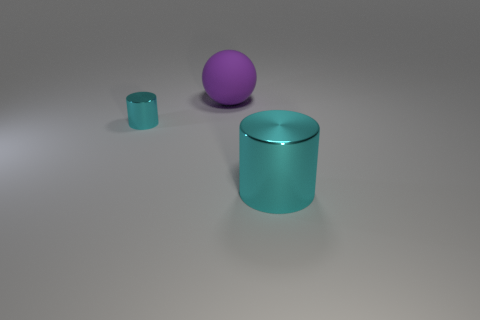Is the color of the thing to the right of the large purple sphere the same as the big thing that is behind the tiny cyan cylinder? no 